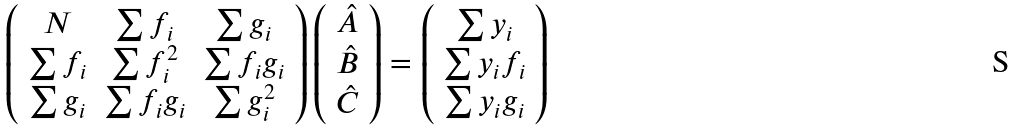Convert formula to latex. <formula><loc_0><loc_0><loc_500><loc_500>\left ( \begin{array} { c c c } N & \sum f _ { i } & \sum g _ { i } \\ \sum f _ { i } & \sum f _ { i } ^ { 2 } & \sum f _ { i } g _ { i } \\ \sum g _ { i } & \sum f _ { i } g _ { i } & \sum g _ { i } ^ { 2 } \\ \end{array} \right ) \left ( \begin{array} { c } \hat { A } \\ \hat { B } \\ \hat { C } \end{array} \right ) = \left ( \begin{array} { c } \sum y _ { i } \\ \sum y _ { i } f _ { i } \\ \sum y _ { i } g _ { i } \\ \end{array} \right )</formula> 